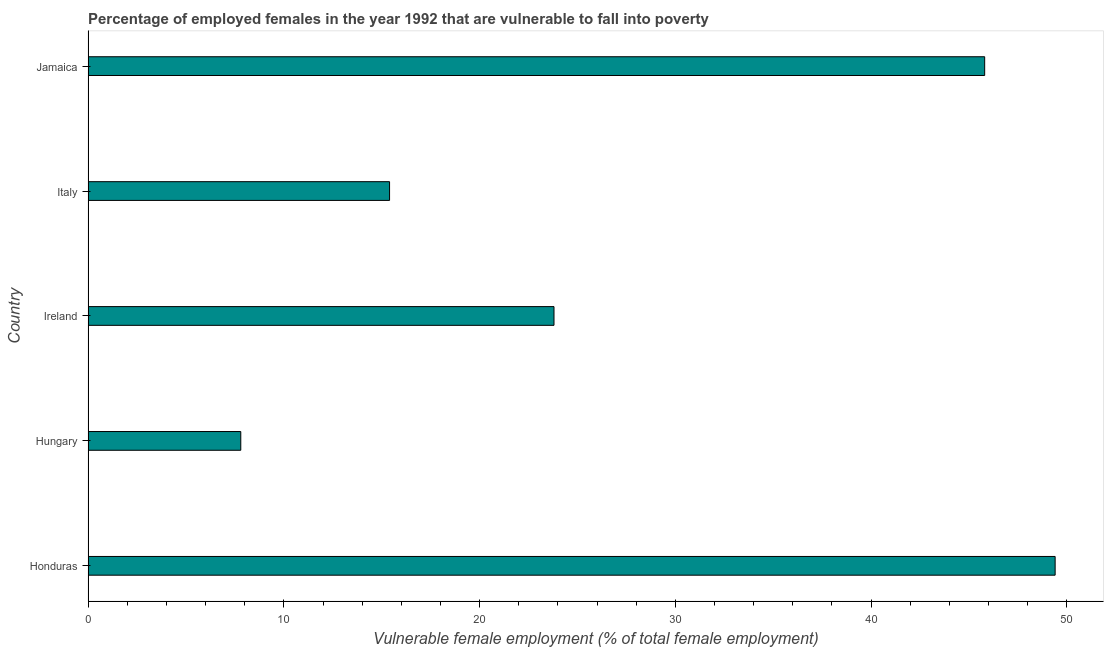Does the graph contain grids?
Give a very brief answer. No. What is the title of the graph?
Offer a very short reply. Percentage of employed females in the year 1992 that are vulnerable to fall into poverty. What is the label or title of the X-axis?
Provide a succinct answer. Vulnerable female employment (% of total female employment). What is the percentage of employed females who are vulnerable to fall into poverty in Honduras?
Offer a terse response. 49.4. Across all countries, what is the maximum percentage of employed females who are vulnerable to fall into poverty?
Give a very brief answer. 49.4. Across all countries, what is the minimum percentage of employed females who are vulnerable to fall into poverty?
Keep it short and to the point. 7.8. In which country was the percentage of employed females who are vulnerable to fall into poverty maximum?
Provide a succinct answer. Honduras. In which country was the percentage of employed females who are vulnerable to fall into poverty minimum?
Offer a terse response. Hungary. What is the sum of the percentage of employed females who are vulnerable to fall into poverty?
Your answer should be compact. 142.2. What is the difference between the percentage of employed females who are vulnerable to fall into poverty in Italy and Jamaica?
Your answer should be very brief. -30.4. What is the average percentage of employed females who are vulnerable to fall into poverty per country?
Your response must be concise. 28.44. What is the median percentage of employed females who are vulnerable to fall into poverty?
Your answer should be compact. 23.8. In how many countries, is the percentage of employed females who are vulnerable to fall into poverty greater than 20 %?
Provide a succinct answer. 3. What is the ratio of the percentage of employed females who are vulnerable to fall into poverty in Hungary to that in Ireland?
Your answer should be compact. 0.33. What is the difference between the highest and the second highest percentage of employed females who are vulnerable to fall into poverty?
Ensure brevity in your answer.  3.6. Is the sum of the percentage of employed females who are vulnerable to fall into poverty in Honduras and Ireland greater than the maximum percentage of employed females who are vulnerable to fall into poverty across all countries?
Ensure brevity in your answer.  Yes. What is the difference between the highest and the lowest percentage of employed females who are vulnerable to fall into poverty?
Provide a short and direct response. 41.6. In how many countries, is the percentage of employed females who are vulnerable to fall into poverty greater than the average percentage of employed females who are vulnerable to fall into poverty taken over all countries?
Make the answer very short. 2. How many bars are there?
Provide a succinct answer. 5. Are all the bars in the graph horizontal?
Ensure brevity in your answer.  Yes. Are the values on the major ticks of X-axis written in scientific E-notation?
Give a very brief answer. No. What is the Vulnerable female employment (% of total female employment) of Honduras?
Provide a succinct answer. 49.4. What is the Vulnerable female employment (% of total female employment) of Hungary?
Ensure brevity in your answer.  7.8. What is the Vulnerable female employment (% of total female employment) of Ireland?
Keep it short and to the point. 23.8. What is the Vulnerable female employment (% of total female employment) of Italy?
Provide a succinct answer. 15.4. What is the Vulnerable female employment (% of total female employment) in Jamaica?
Give a very brief answer. 45.8. What is the difference between the Vulnerable female employment (% of total female employment) in Honduras and Hungary?
Give a very brief answer. 41.6. What is the difference between the Vulnerable female employment (% of total female employment) in Honduras and Ireland?
Offer a very short reply. 25.6. What is the difference between the Vulnerable female employment (% of total female employment) in Honduras and Italy?
Ensure brevity in your answer.  34. What is the difference between the Vulnerable female employment (% of total female employment) in Honduras and Jamaica?
Keep it short and to the point. 3.6. What is the difference between the Vulnerable female employment (% of total female employment) in Hungary and Ireland?
Ensure brevity in your answer.  -16. What is the difference between the Vulnerable female employment (% of total female employment) in Hungary and Jamaica?
Provide a succinct answer. -38. What is the difference between the Vulnerable female employment (% of total female employment) in Ireland and Italy?
Make the answer very short. 8.4. What is the difference between the Vulnerable female employment (% of total female employment) in Ireland and Jamaica?
Give a very brief answer. -22. What is the difference between the Vulnerable female employment (% of total female employment) in Italy and Jamaica?
Give a very brief answer. -30.4. What is the ratio of the Vulnerable female employment (% of total female employment) in Honduras to that in Hungary?
Offer a terse response. 6.33. What is the ratio of the Vulnerable female employment (% of total female employment) in Honduras to that in Ireland?
Ensure brevity in your answer.  2.08. What is the ratio of the Vulnerable female employment (% of total female employment) in Honduras to that in Italy?
Your answer should be very brief. 3.21. What is the ratio of the Vulnerable female employment (% of total female employment) in Honduras to that in Jamaica?
Offer a terse response. 1.08. What is the ratio of the Vulnerable female employment (% of total female employment) in Hungary to that in Ireland?
Offer a terse response. 0.33. What is the ratio of the Vulnerable female employment (% of total female employment) in Hungary to that in Italy?
Ensure brevity in your answer.  0.51. What is the ratio of the Vulnerable female employment (% of total female employment) in Hungary to that in Jamaica?
Your answer should be compact. 0.17. What is the ratio of the Vulnerable female employment (% of total female employment) in Ireland to that in Italy?
Your response must be concise. 1.54. What is the ratio of the Vulnerable female employment (% of total female employment) in Ireland to that in Jamaica?
Provide a short and direct response. 0.52. What is the ratio of the Vulnerable female employment (% of total female employment) in Italy to that in Jamaica?
Keep it short and to the point. 0.34. 